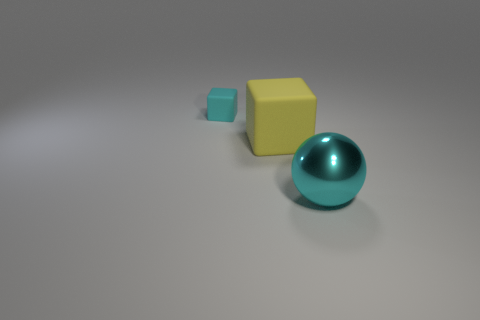Add 2 large yellow rubber spheres. How many objects exist? 5 Subtract all cubes. How many objects are left? 1 Subtract all cyan shiny objects. Subtract all cyan metal balls. How many objects are left? 1 Add 1 small rubber things. How many small rubber things are left? 2 Add 1 metallic objects. How many metallic objects exist? 2 Subtract 0 blue spheres. How many objects are left? 3 